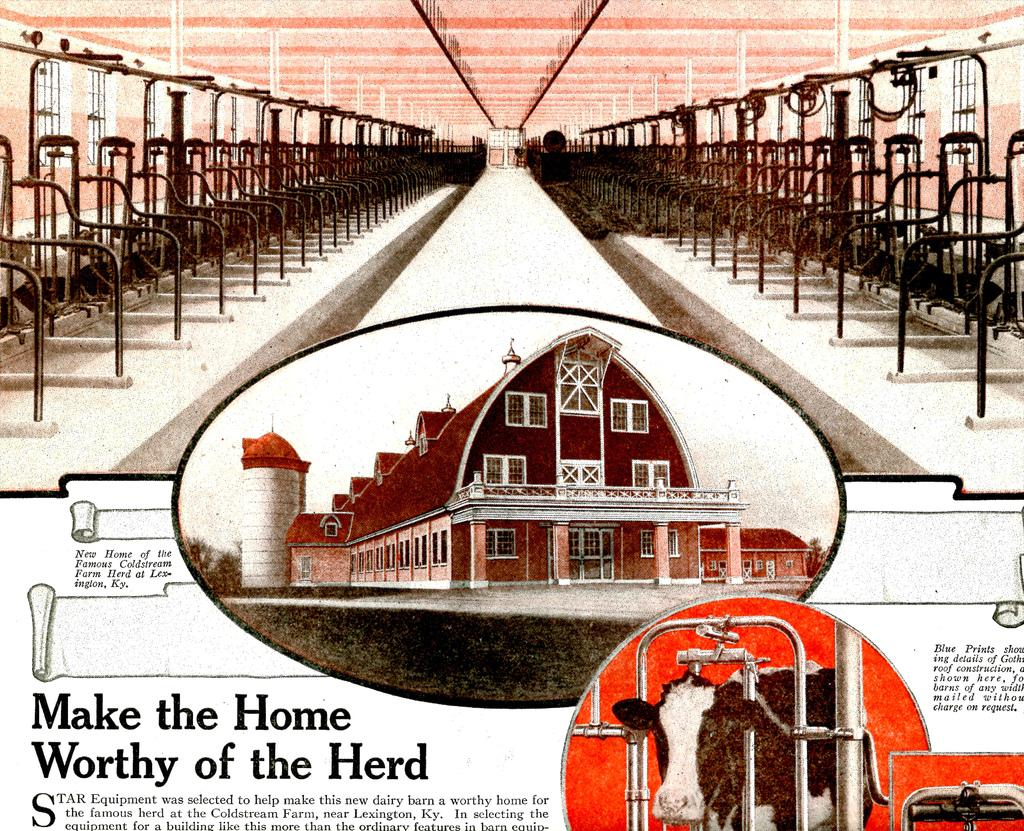Provide a one-sentence caption for the provided image. An article showcasing a barn with the title make the home worthy of the herd. 